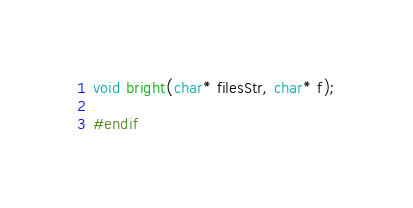<code> <loc_0><loc_0><loc_500><loc_500><_C_>void bright(char* filesStr, char* f);

#endif
</code> 